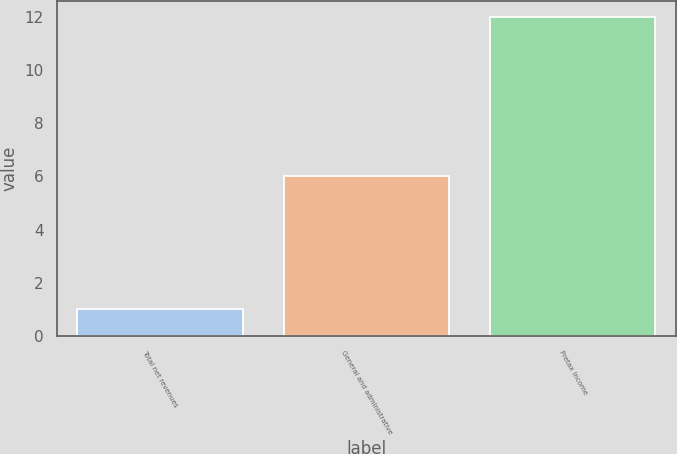Convert chart to OTSL. <chart><loc_0><loc_0><loc_500><loc_500><bar_chart><fcel>Total net revenues<fcel>General and administrative<fcel>Pretax income<nl><fcel>1<fcel>6<fcel>12<nl></chart> 